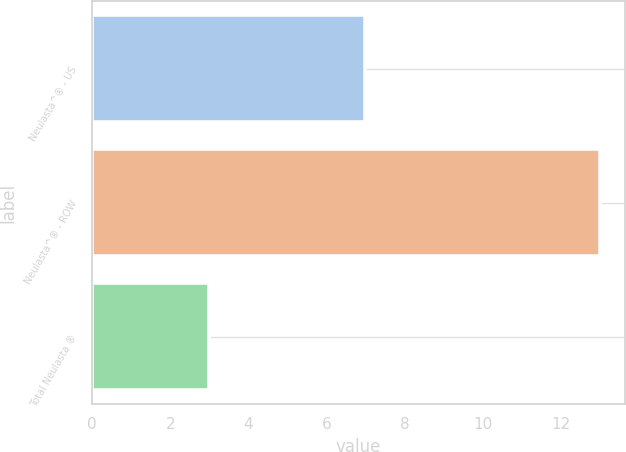Convert chart. <chart><loc_0><loc_0><loc_500><loc_500><bar_chart><fcel>Neulasta^® - US<fcel>Neulasta^® - ROW<fcel>Total Neulasta ®<nl><fcel>7<fcel>13<fcel>3<nl></chart> 